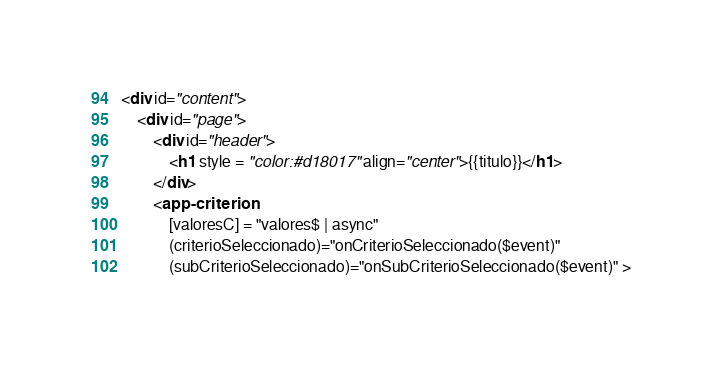<code> <loc_0><loc_0><loc_500><loc_500><_HTML_><div id="content">
    <div id="page">
        <div id="header">
            <h1 style = "color:#d18017" align="center">{{titulo}}</h1>
        </div>
        <app-criterion            
            [valoresC] = "valores$ | async"            
            (criterioSeleccionado)="onCriterioSeleccionado($event)"
            (subCriterioSeleccionado)="onSubCriterioSeleccionado($event)" ></code> 